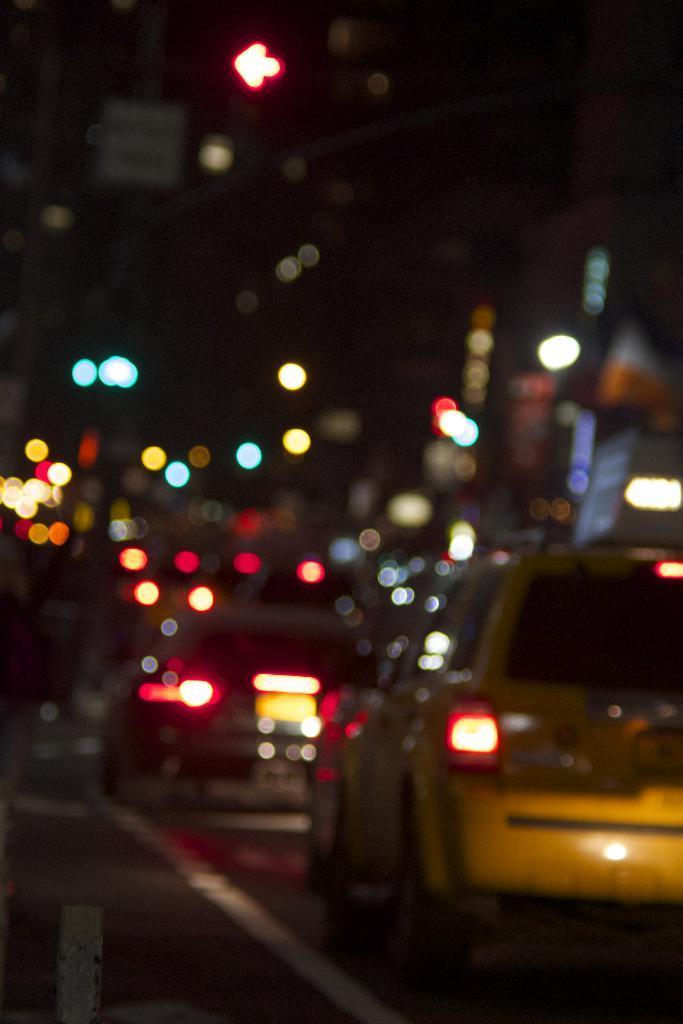How would you summarize this image in a sentence or two? In this blur image, we can see cars and some lights. 